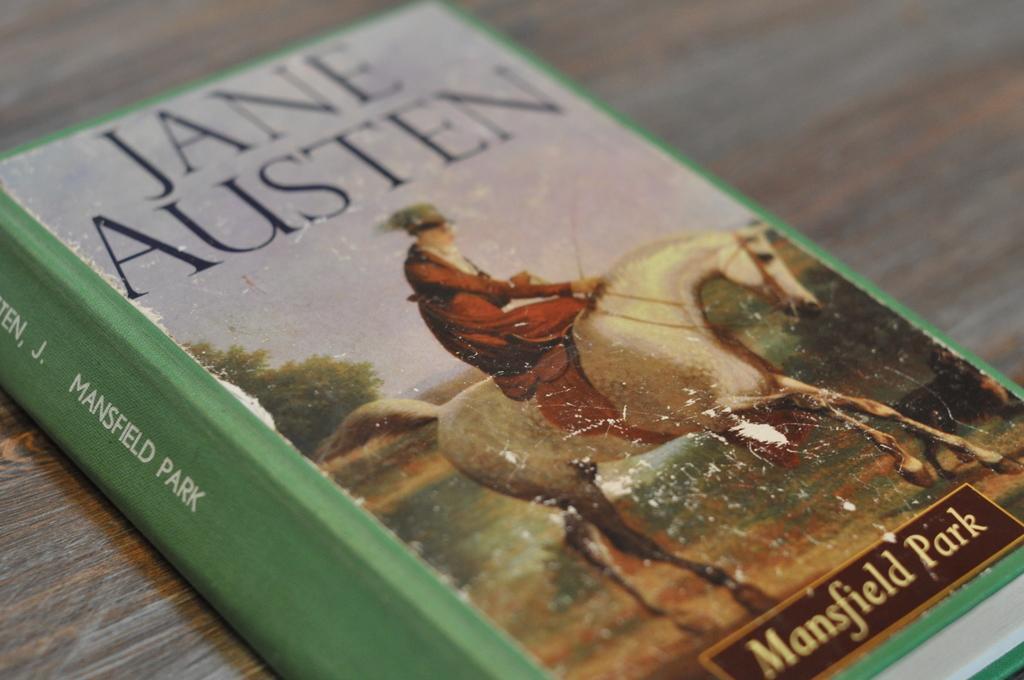Describe this image in one or two sentences. In the picture we can see a book on the table and the name of the book is Jane Austen and under it we can see an image of a person sitting on a horse. 